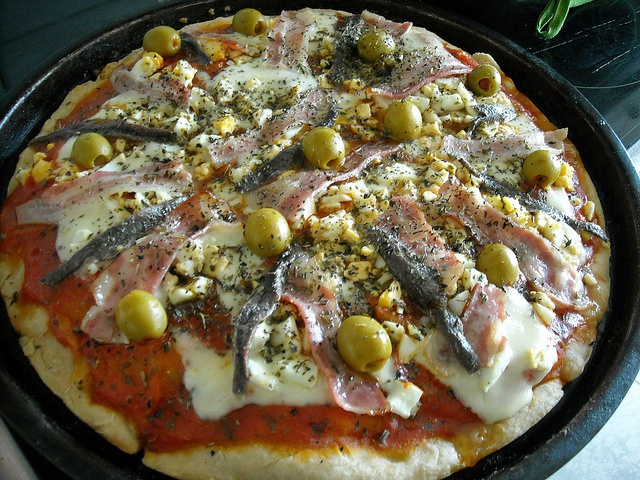Describe the objects in this image and their specific colors. I can see a pizza in black, maroon, olive, and darkgray tones in this image. 